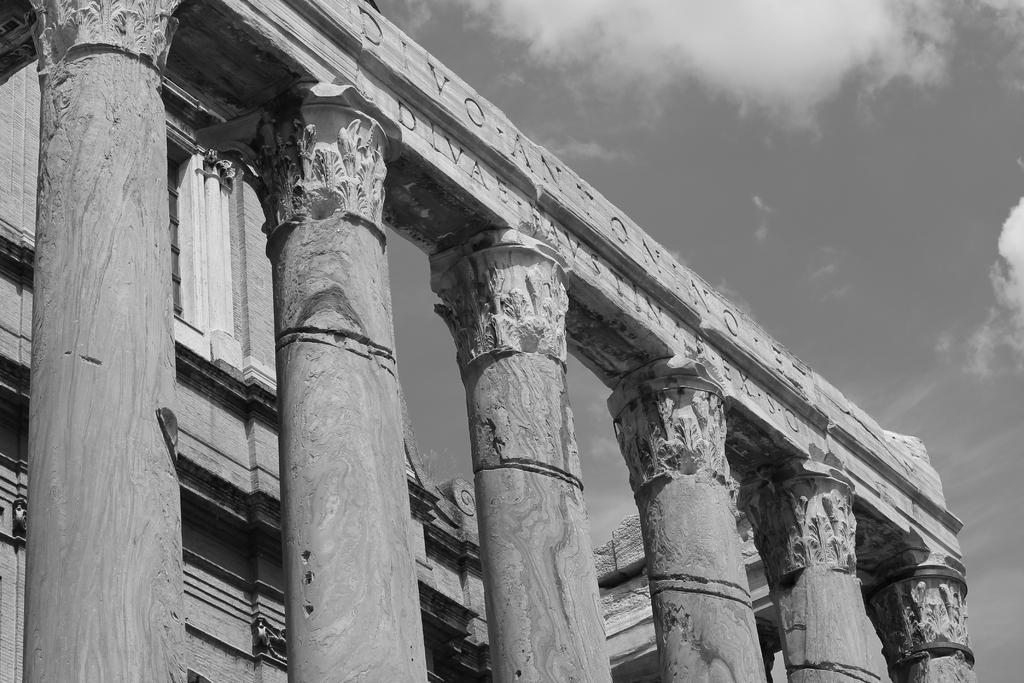Describe this image in one or two sentences. This image consists of a building. In the front, we can see the pillars. At the top, we can see the text on the beam. At the top, there are clouds in the sky. 